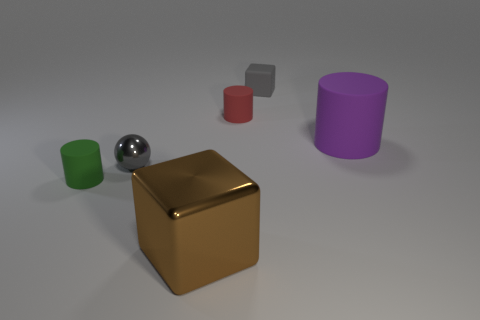Add 4 tiny gray matte objects. How many objects exist? 10 Subtract all blocks. How many objects are left? 4 Add 1 brown metallic things. How many brown metallic things exist? 2 Subtract 0 red balls. How many objects are left? 6 Subtract all green cubes. Subtract all metal things. How many objects are left? 4 Add 4 brown metal objects. How many brown metal objects are left? 5 